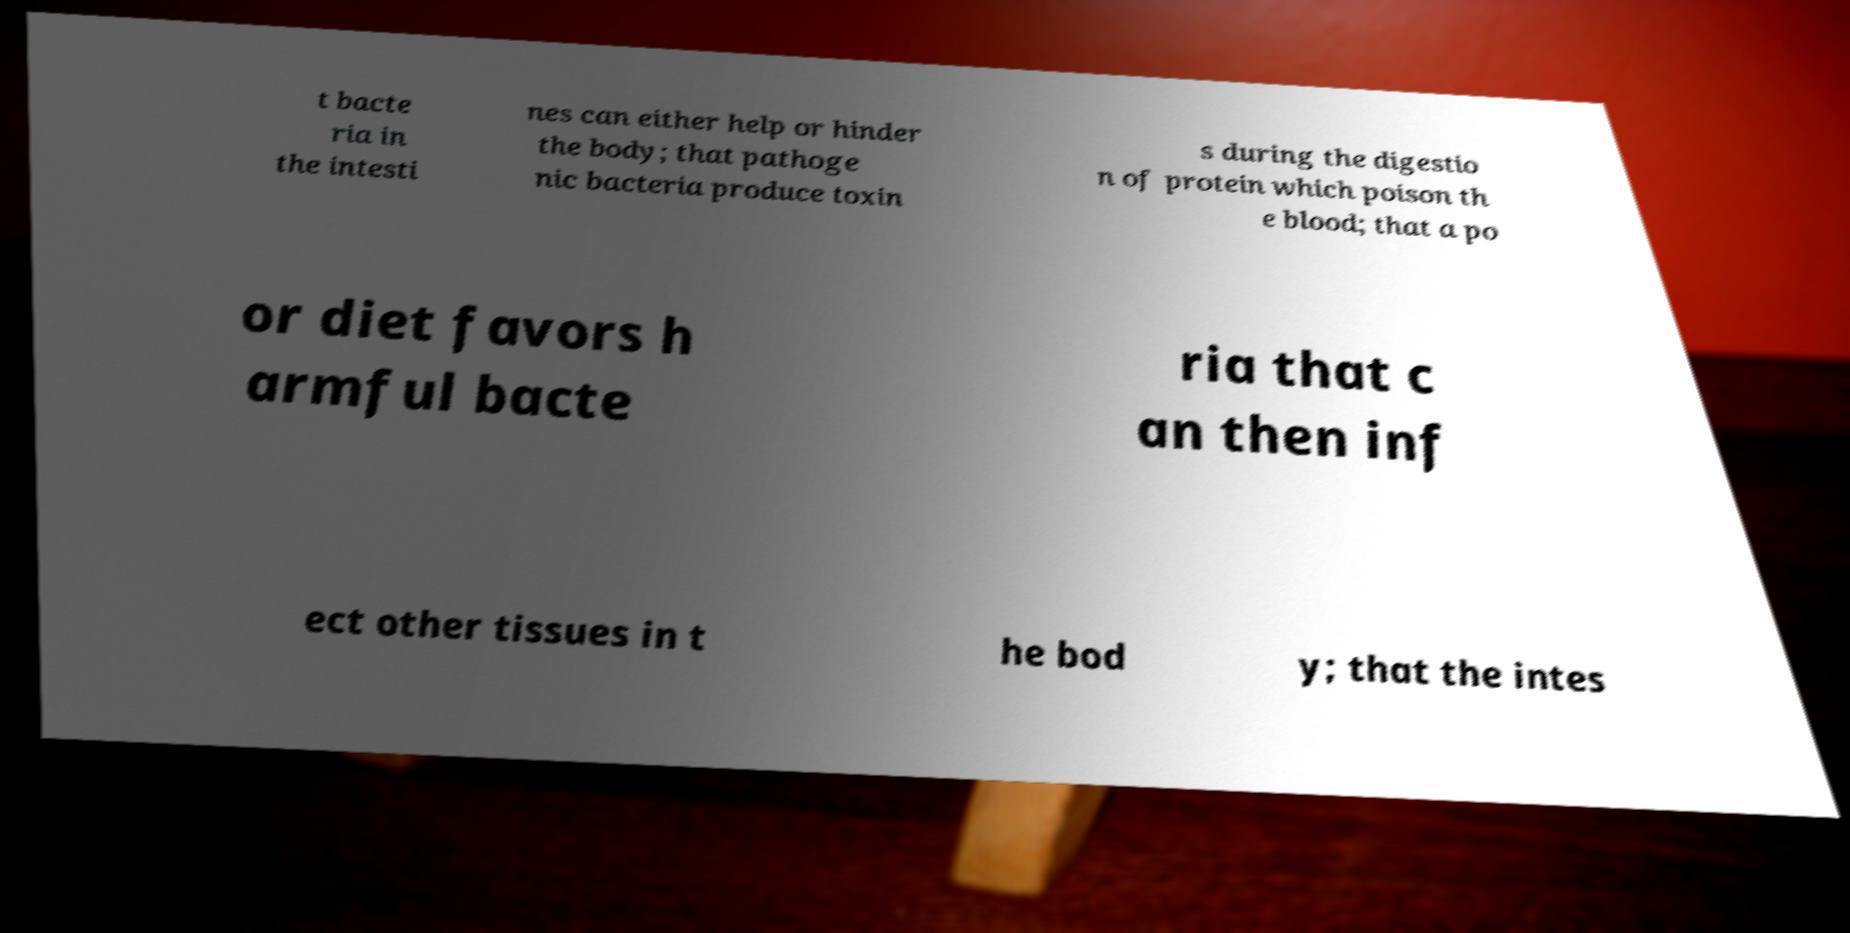Please identify and transcribe the text found in this image. t bacte ria in the intesti nes can either help or hinder the body; that pathoge nic bacteria produce toxin s during the digestio n of protein which poison th e blood; that a po or diet favors h armful bacte ria that c an then inf ect other tissues in t he bod y; that the intes 